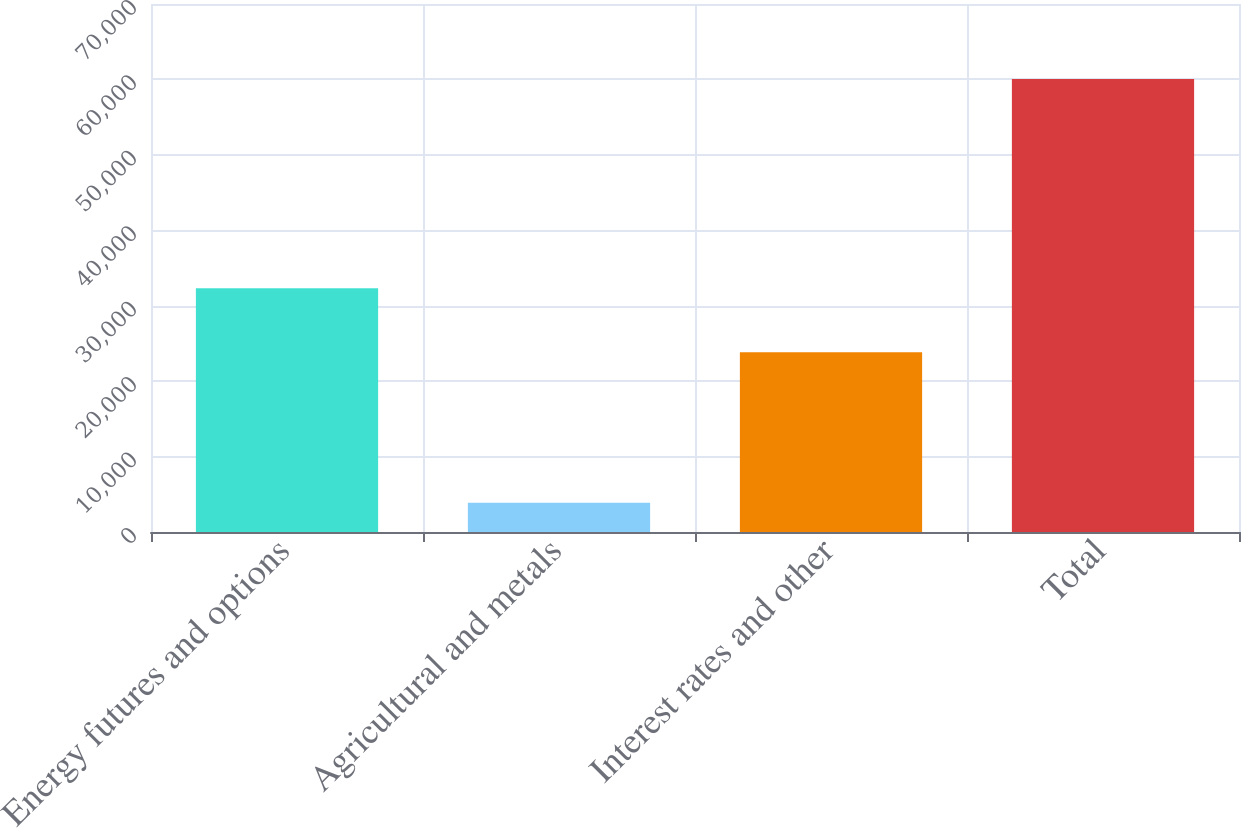Convert chart. <chart><loc_0><loc_0><loc_500><loc_500><bar_chart><fcel>Energy futures and options<fcel>Agricultural and metals<fcel>Interest rates and other<fcel>Total<nl><fcel>32329<fcel>3878<fcel>23834<fcel>60041<nl></chart> 